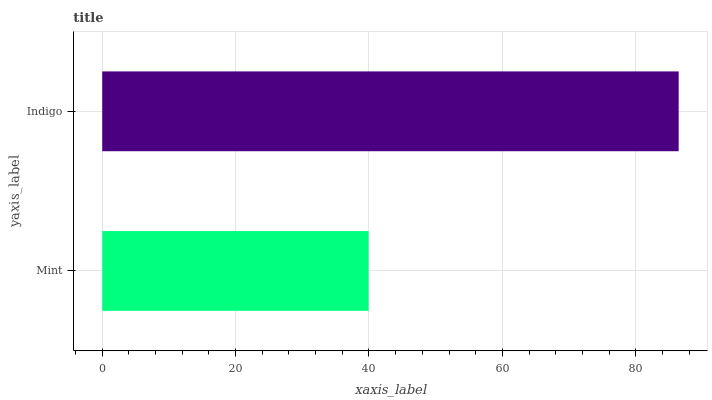Is Mint the minimum?
Answer yes or no. Yes. Is Indigo the maximum?
Answer yes or no. Yes. Is Indigo the minimum?
Answer yes or no. No. Is Indigo greater than Mint?
Answer yes or no. Yes. Is Mint less than Indigo?
Answer yes or no. Yes. Is Mint greater than Indigo?
Answer yes or no. No. Is Indigo less than Mint?
Answer yes or no. No. Is Indigo the high median?
Answer yes or no. Yes. Is Mint the low median?
Answer yes or no. Yes. Is Mint the high median?
Answer yes or no. No. Is Indigo the low median?
Answer yes or no. No. 